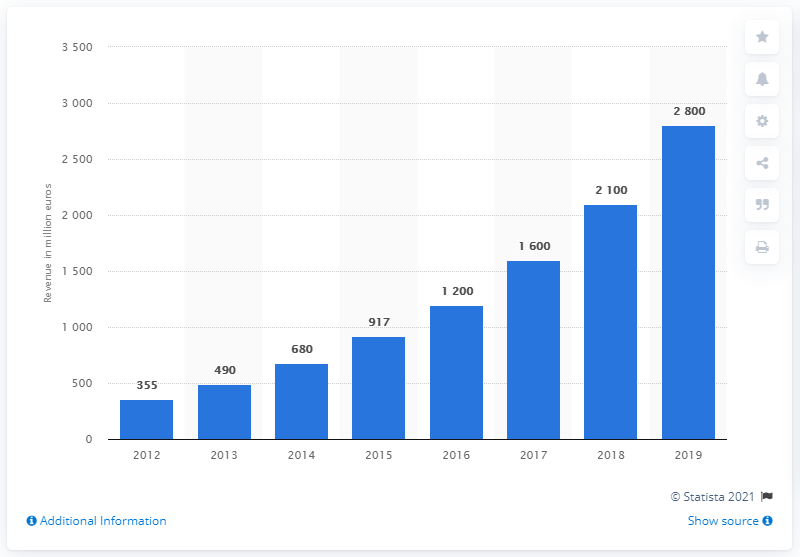Specify some key components in this picture. In 2019, the net consumer sales on Bol.com amounted to 2,800. 